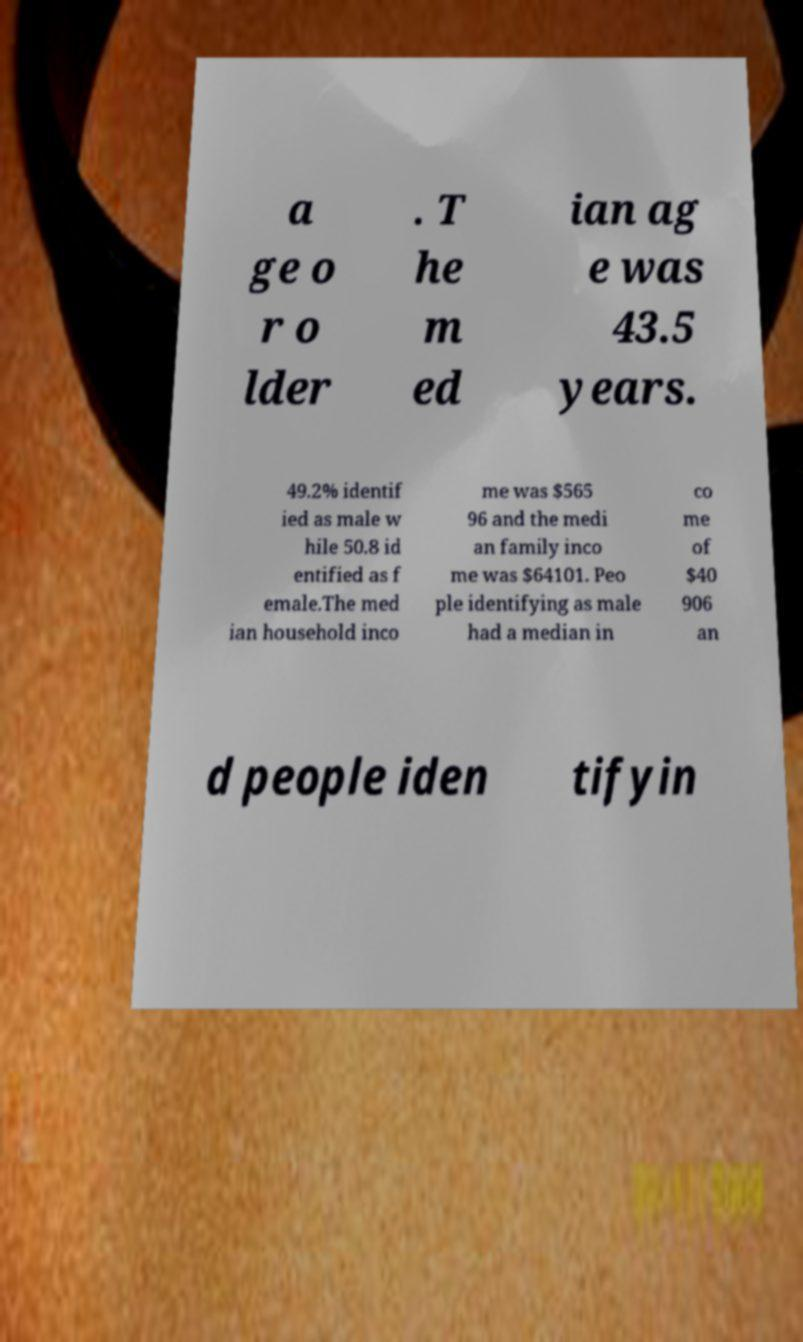There's text embedded in this image that I need extracted. Can you transcribe it verbatim? a ge o r o lder . T he m ed ian ag e was 43.5 years. 49.2% identif ied as male w hile 50.8 id entified as f emale.The med ian household inco me was $565 96 and the medi an family inco me was $64101. Peo ple identifying as male had a median in co me of $40 906 an d people iden tifyin 